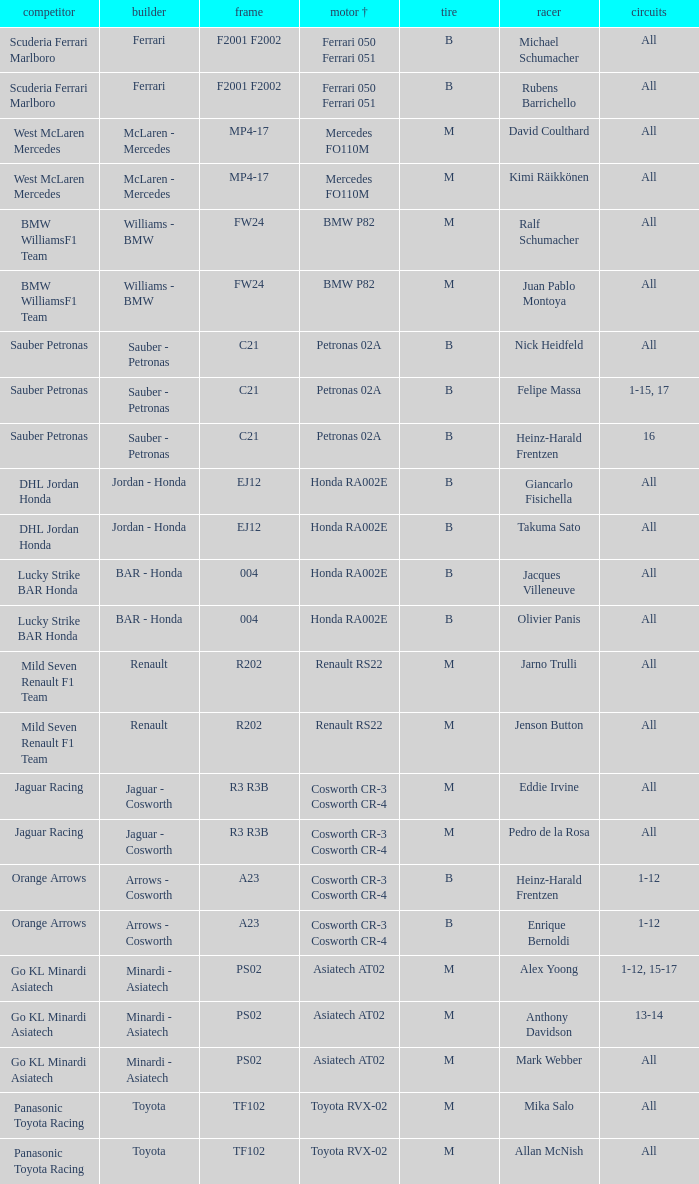When the driver is alex yoong and the engine is asiatech at02, what type of tyre is used? M. 